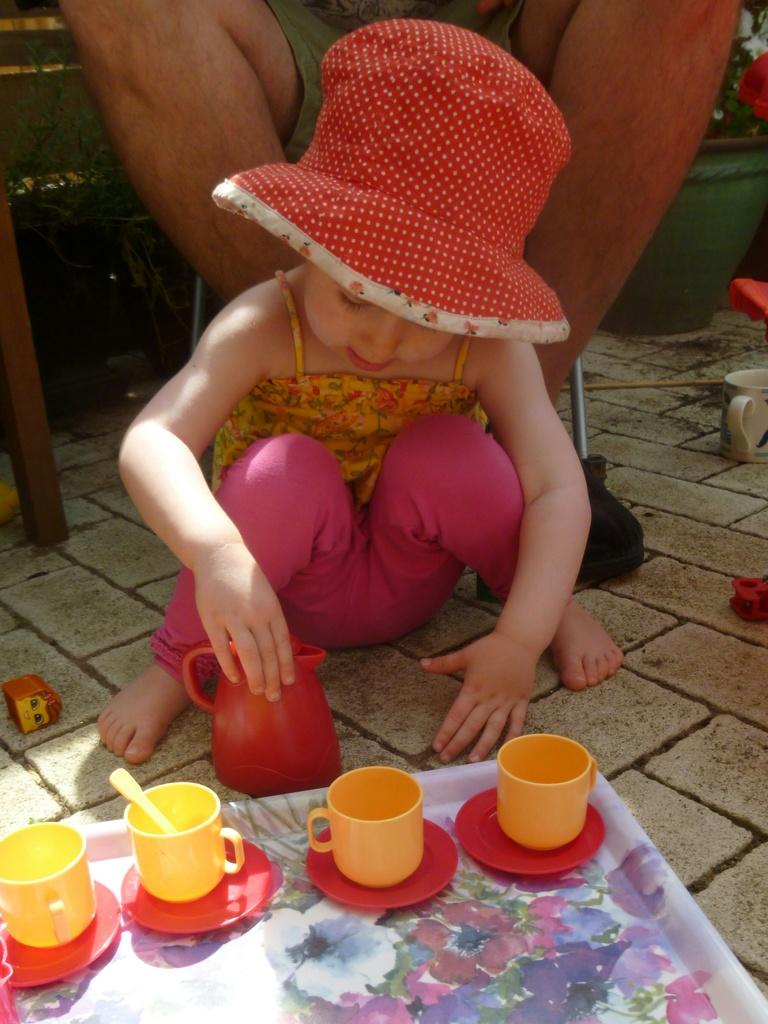Who is the main subject in the image? There is a little girl in the image. What is the girl doing in the image? The girl is sitting on the floor. What is in front of the girl? There is a tea tray in front of the girl. What is on the tea tray? The tea tray has tea cups on it. Who else is present in the image? There is a man in the image. What is the man doing in the image? The man is sitting on a chair. Where is the man in relation to the girl? The man is sitting behind the girl. What type of vegetable is the girl holding in the image? There is no vegetable present in the image; the girl is sitting on the floor with a tea tray in front of her. 